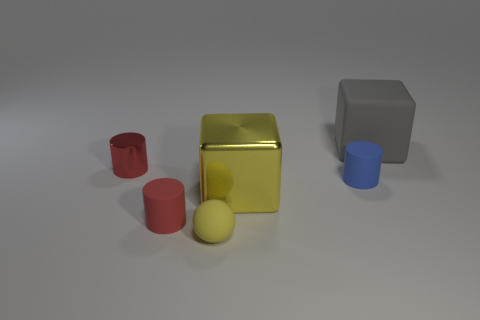Subtract all tiny rubber cylinders. How many cylinders are left? 1 Add 4 large blue matte cylinders. How many objects exist? 10 Subtract all yellow cubes. How many cubes are left? 1 Subtract 1 cubes. How many cubes are left? 1 Subtract all blocks. How many objects are left? 4 Add 3 things. How many things exist? 9 Subtract 0 red cubes. How many objects are left? 6 Subtract all blue cylinders. Subtract all purple blocks. How many cylinders are left? 2 Subtract all blue cylinders. How many gray blocks are left? 1 Subtract all small green cylinders. Subtract all cylinders. How many objects are left? 3 